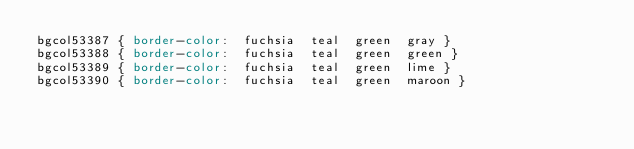Convert code to text. <code><loc_0><loc_0><loc_500><loc_500><_CSS_>bgcol53387 { border-color:  fuchsia  teal  green  gray }
bgcol53388 { border-color:  fuchsia  teal  green  green }
bgcol53389 { border-color:  fuchsia  teal  green  lime }
bgcol53390 { border-color:  fuchsia  teal  green  maroon }</code> 